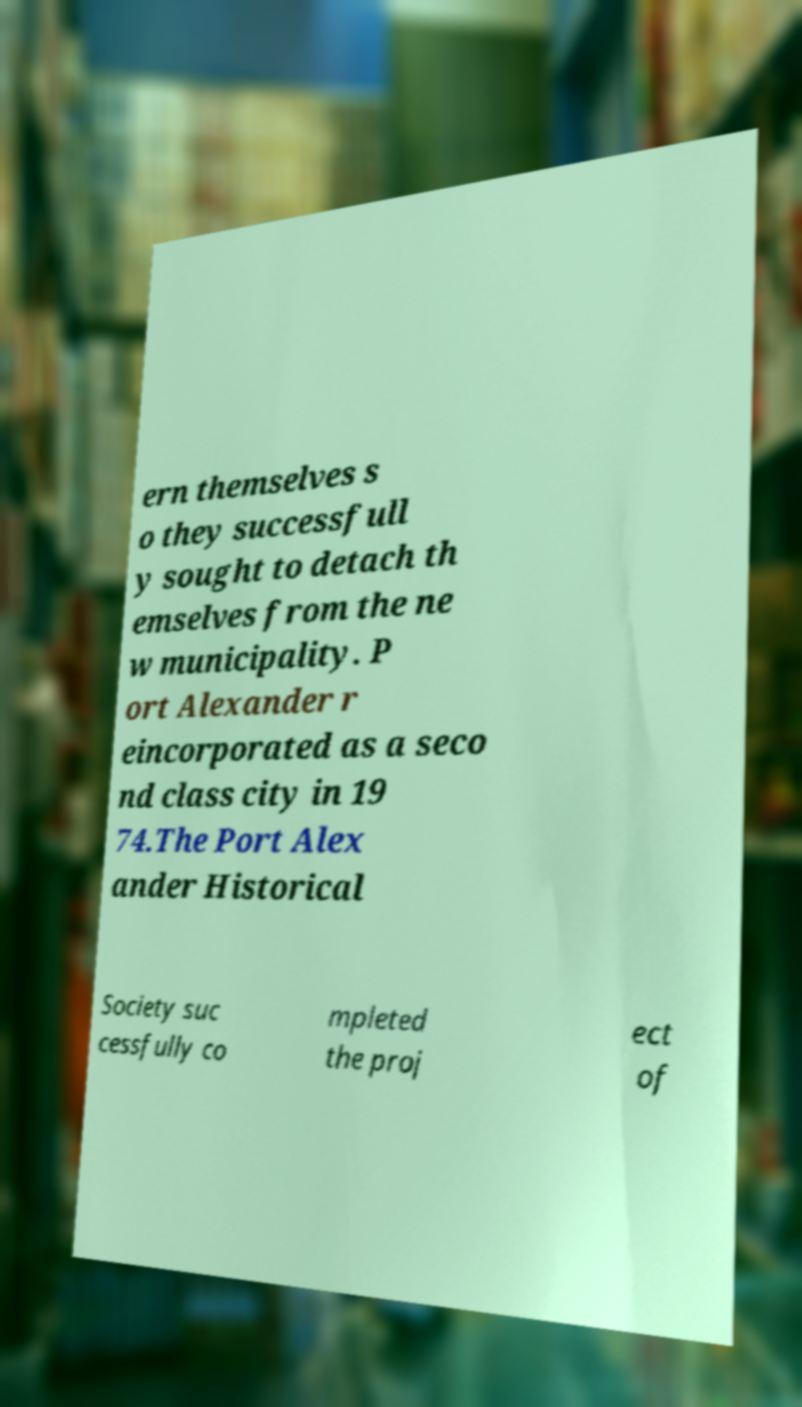Could you extract and type out the text from this image? ern themselves s o they successfull y sought to detach th emselves from the ne w municipality. P ort Alexander r eincorporated as a seco nd class city in 19 74.The Port Alex ander Historical Society suc cessfully co mpleted the proj ect of 